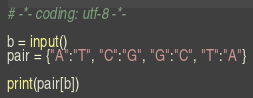<code> <loc_0><loc_0><loc_500><loc_500><_Python_># -*- coding: utf-8 -*-

b = input()
pair = {"A":"T", "C":"G", "G":"C", "T":"A"}

print(pair[b])
</code> 